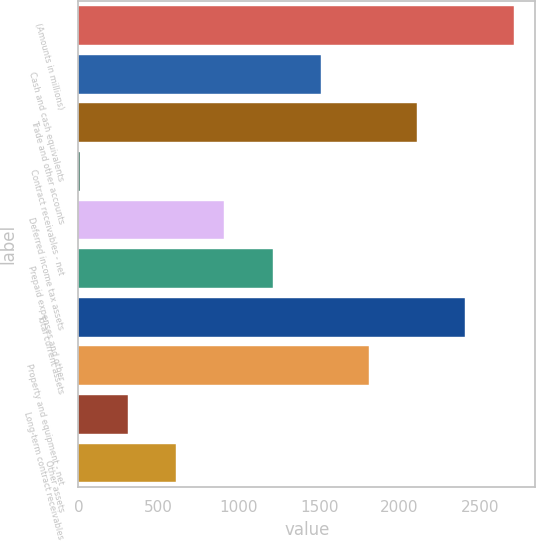<chart> <loc_0><loc_0><loc_500><loc_500><bar_chart><fcel>(Amounts in millions)<fcel>Cash and cash equivalents<fcel>Trade and other accounts<fcel>Contract receivables - net<fcel>Deferred income tax assets<fcel>Prepaid expenses and other<fcel>Total current assets<fcel>Property and equipment - net<fcel>Long-term contract receivables<fcel>Other assets<nl><fcel>2711.72<fcel>1509.8<fcel>2110.76<fcel>7.4<fcel>908.84<fcel>1209.32<fcel>2411.24<fcel>1810.28<fcel>307.88<fcel>608.36<nl></chart> 